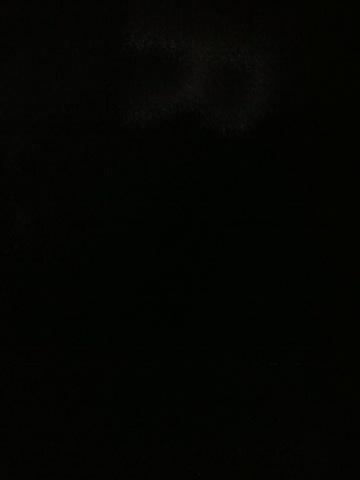Create another realistic scenario of this dark image in a short response. This could be a photograph taken in a dimly lit room, perhaps during a power outage. The lack of light makes it challenging to see any details, emphasizing the sudden plunge into darkness. 